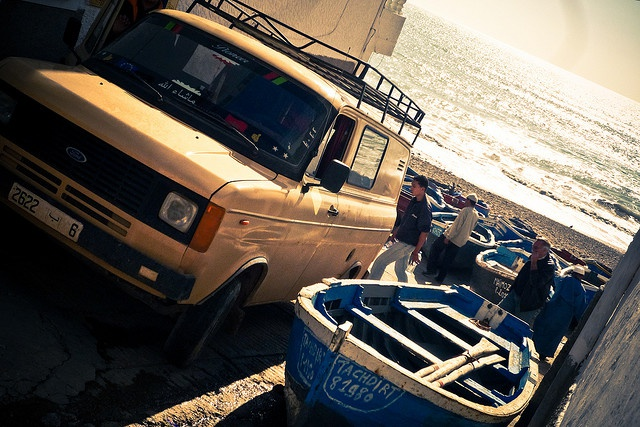Describe the objects in this image and their specific colors. I can see truck in black, gray, maroon, and khaki tones, car in black, gray, khaki, and maroon tones, boat in black, navy, beige, and gray tones, people in black, navy, ivory, and tan tones, and people in black, gray, and maroon tones in this image. 